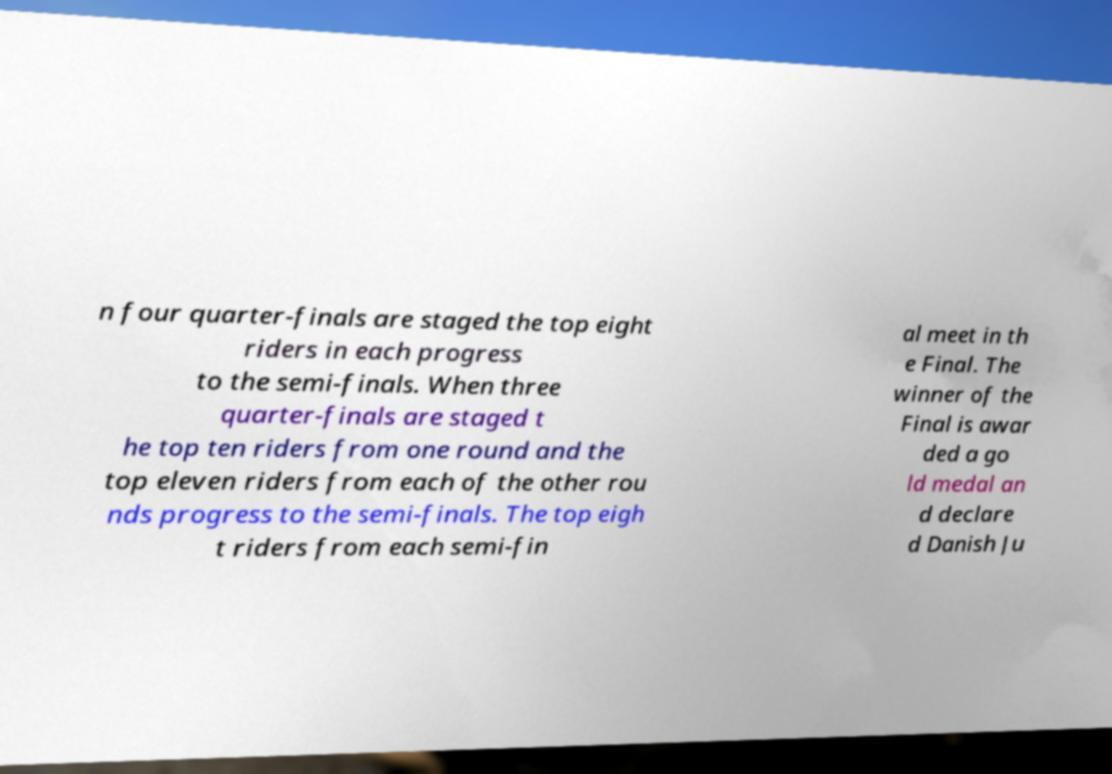Please identify and transcribe the text found in this image. n four quarter-finals are staged the top eight riders in each progress to the semi-finals. When three quarter-finals are staged t he top ten riders from one round and the top eleven riders from each of the other rou nds progress to the semi-finals. The top eigh t riders from each semi-fin al meet in th e Final. The winner of the Final is awar ded a go ld medal an d declare d Danish Ju 